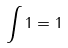<formula> <loc_0><loc_0><loc_500><loc_500>\int 1 = 1</formula> 